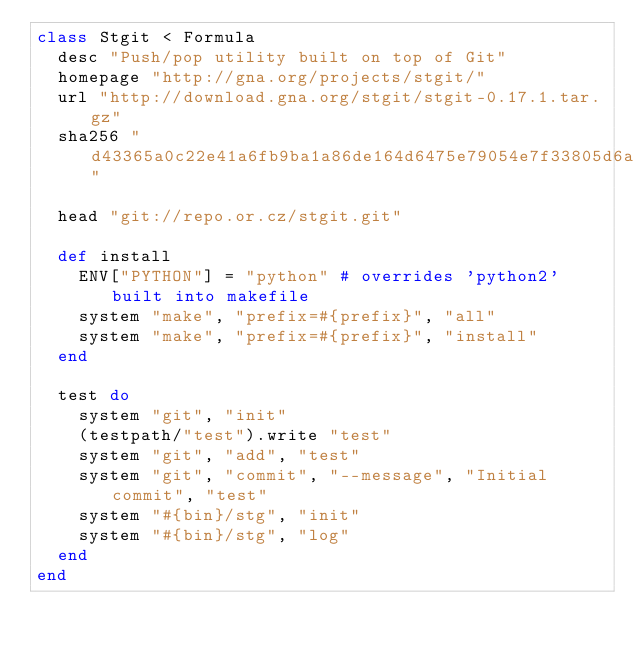Convert code to text. <code><loc_0><loc_0><loc_500><loc_500><_Ruby_>class Stgit < Formula
  desc "Push/pop utility built on top of Git"
  homepage "http://gna.org/projects/stgit/"
  url "http://download.gna.org/stgit/stgit-0.17.1.tar.gz"
  sha256 "d43365a0c22e41a6fb9ba1a86de164d6475e79054e7f33805d6a829eb4056ade"

  head "git://repo.or.cz/stgit.git"

  def install
    ENV["PYTHON"] = "python" # overrides 'python2' built into makefile
    system "make", "prefix=#{prefix}", "all"
    system "make", "prefix=#{prefix}", "install"
  end

  test do
    system "git", "init"
    (testpath/"test").write "test"
    system "git", "add", "test"
    system "git", "commit", "--message", "Initial commit", "test"
    system "#{bin}/stg", "init"
    system "#{bin}/stg", "log"
  end
end
</code> 